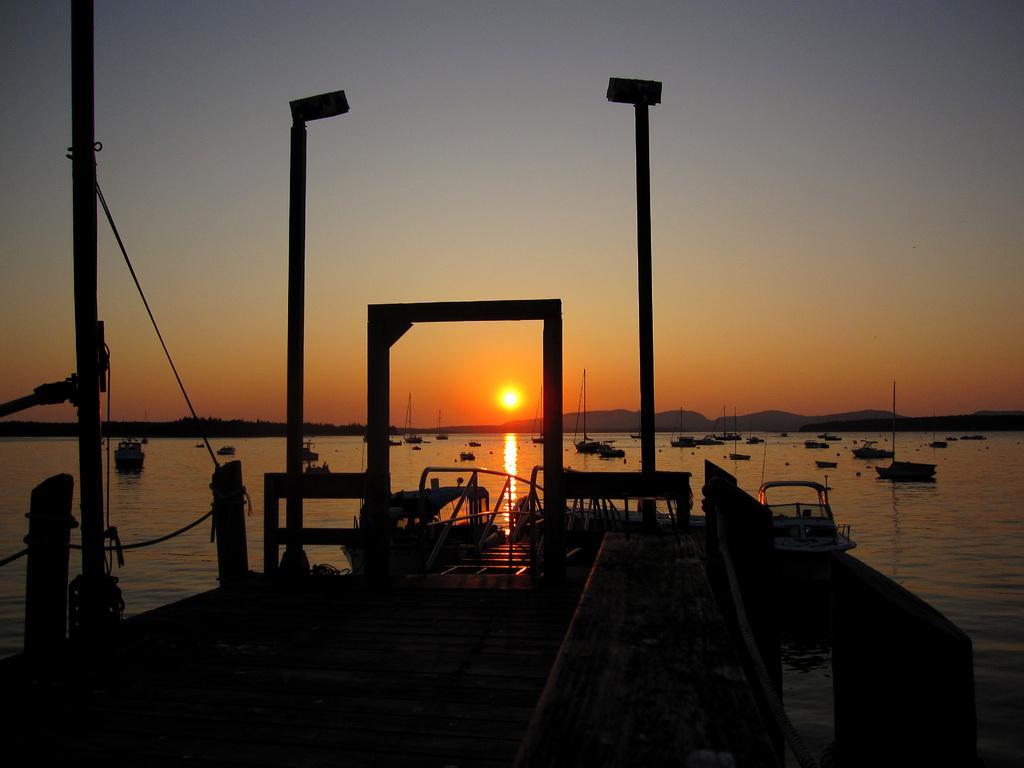What is depicted in the image? There are boats in the image. Where are the boats located? The boats are on a river. What can be seen in the background of the image? There are mountains in the background of the image. What time of day is depicted in the image? There is a sunrise visible in the sky, indicating that it is early morning. What type of egg is being cooked on the boat in the image? There is no egg or cooking activity depicted in the image; it only shows boats on a river with mountains in the background and a sunrise in the sky. 